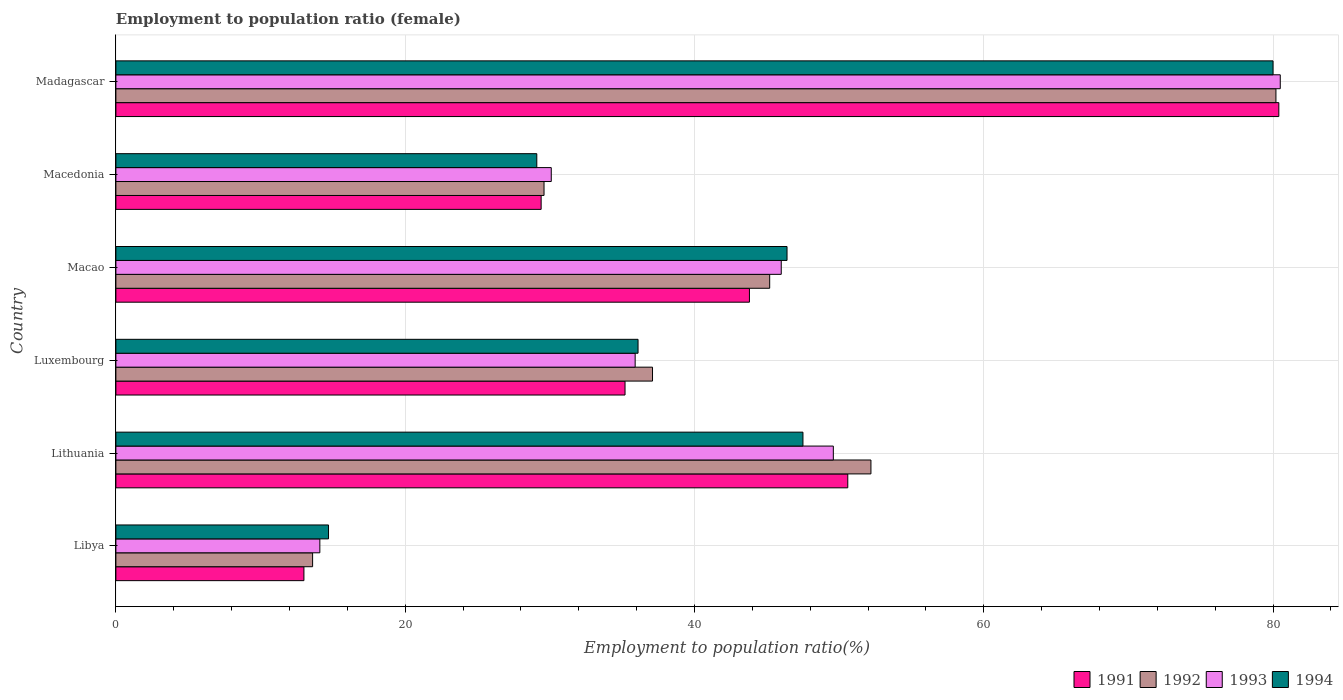How many different coloured bars are there?
Provide a succinct answer. 4. How many groups of bars are there?
Give a very brief answer. 6. Are the number of bars on each tick of the Y-axis equal?
Your response must be concise. Yes. How many bars are there on the 4th tick from the top?
Keep it short and to the point. 4. What is the label of the 6th group of bars from the top?
Keep it short and to the point. Libya. What is the employment to population ratio in 1994 in Luxembourg?
Make the answer very short. 36.1. Across all countries, what is the maximum employment to population ratio in 1991?
Offer a very short reply. 80.4. Across all countries, what is the minimum employment to population ratio in 1993?
Ensure brevity in your answer.  14.1. In which country was the employment to population ratio in 1991 maximum?
Offer a very short reply. Madagascar. In which country was the employment to population ratio in 1994 minimum?
Give a very brief answer. Libya. What is the total employment to population ratio in 1991 in the graph?
Ensure brevity in your answer.  252.4. What is the difference between the employment to population ratio in 1994 in Lithuania and that in Macedonia?
Your response must be concise. 18.4. What is the difference between the employment to population ratio in 1991 in Macao and the employment to population ratio in 1994 in Luxembourg?
Offer a very short reply. 7.7. What is the average employment to population ratio in 1992 per country?
Offer a terse response. 42.98. What is the difference between the employment to population ratio in 1992 and employment to population ratio in 1993 in Macao?
Your response must be concise. -0.8. What is the ratio of the employment to population ratio in 1992 in Luxembourg to that in Madagascar?
Provide a succinct answer. 0.46. Is the employment to population ratio in 1991 in Libya less than that in Macedonia?
Keep it short and to the point. Yes. What is the difference between the highest and the second highest employment to population ratio in 1994?
Offer a very short reply. 32.5. What is the difference between the highest and the lowest employment to population ratio in 1994?
Provide a succinct answer. 65.3. Is it the case that in every country, the sum of the employment to population ratio in 1994 and employment to population ratio in 1993 is greater than the sum of employment to population ratio in 1992 and employment to population ratio in 1991?
Give a very brief answer. No. What does the 1st bar from the bottom in Libya represents?
Ensure brevity in your answer.  1991. Is it the case that in every country, the sum of the employment to population ratio in 1992 and employment to population ratio in 1994 is greater than the employment to population ratio in 1993?
Give a very brief answer. Yes. What is the difference between two consecutive major ticks on the X-axis?
Offer a terse response. 20. Are the values on the major ticks of X-axis written in scientific E-notation?
Provide a short and direct response. No. Does the graph contain any zero values?
Your answer should be compact. No. Where does the legend appear in the graph?
Give a very brief answer. Bottom right. What is the title of the graph?
Provide a short and direct response. Employment to population ratio (female). Does "1994" appear as one of the legend labels in the graph?
Your answer should be compact. Yes. What is the label or title of the X-axis?
Provide a succinct answer. Employment to population ratio(%). What is the label or title of the Y-axis?
Ensure brevity in your answer.  Country. What is the Employment to population ratio(%) in 1991 in Libya?
Ensure brevity in your answer.  13. What is the Employment to population ratio(%) of 1992 in Libya?
Provide a short and direct response. 13.6. What is the Employment to population ratio(%) in 1993 in Libya?
Give a very brief answer. 14.1. What is the Employment to population ratio(%) in 1994 in Libya?
Your answer should be very brief. 14.7. What is the Employment to population ratio(%) in 1991 in Lithuania?
Your answer should be very brief. 50.6. What is the Employment to population ratio(%) in 1992 in Lithuania?
Offer a terse response. 52.2. What is the Employment to population ratio(%) of 1993 in Lithuania?
Provide a short and direct response. 49.6. What is the Employment to population ratio(%) of 1994 in Lithuania?
Give a very brief answer. 47.5. What is the Employment to population ratio(%) of 1991 in Luxembourg?
Offer a terse response. 35.2. What is the Employment to population ratio(%) in 1992 in Luxembourg?
Offer a terse response. 37.1. What is the Employment to population ratio(%) in 1993 in Luxembourg?
Give a very brief answer. 35.9. What is the Employment to population ratio(%) in 1994 in Luxembourg?
Offer a very short reply. 36.1. What is the Employment to population ratio(%) of 1991 in Macao?
Your answer should be very brief. 43.8. What is the Employment to population ratio(%) in 1992 in Macao?
Offer a terse response. 45.2. What is the Employment to population ratio(%) of 1994 in Macao?
Offer a terse response. 46.4. What is the Employment to population ratio(%) in 1991 in Macedonia?
Provide a short and direct response. 29.4. What is the Employment to population ratio(%) in 1992 in Macedonia?
Keep it short and to the point. 29.6. What is the Employment to population ratio(%) in 1993 in Macedonia?
Provide a short and direct response. 30.1. What is the Employment to population ratio(%) in 1994 in Macedonia?
Ensure brevity in your answer.  29.1. What is the Employment to population ratio(%) of 1991 in Madagascar?
Give a very brief answer. 80.4. What is the Employment to population ratio(%) in 1992 in Madagascar?
Make the answer very short. 80.2. What is the Employment to population ratio(%) of 1993 in Madagascar?
Offer a terse response. 80.5. What is the Employment to population ratio(%) of 1994 in Madagascar?
Your answer should be compact. 80. Across all countries, what is the maximum Employment to population ratio(%) in 1991?
Offer a very short reply. 80.4. Across all countries, what is the maximum Employment to population ratio(%) in 1992?
Your answer should be very brief. 80.2. Across all countries, what is the maximum Employment to population ratio(%) in 1993?
Your answer should be very brief. 80.5. Across all countries, what is the minimum Employment to population ratio(%) in 1992?
Offer a terse response. 13.6. Across all countries, what is the minimum Employment to population ratio(%) of 1993?
Ensure brevity in your answer.  14.1. Across all countries, what is the minimum Employment to population ratio(%) of 1994?
Your answer should be compact. 14.7. What is the total Employment to population ratio(%) in 1991 in the graph?
Your response must be concise. 252.4. What is the total Employment to population ratio(%) of 1992 in the graph?
Your answer should be compact. 257.9. What is the total Employment to population ratio(%) of 1993 in the graph?
Keep it short and to the point. 256.2. What is the total Employment to population ratio(%) in 1994 in the graph?
Make the answer very short. 253.8. What is the difference between the Employment to population ratio(%) in 1991 in Libya and that in Lithuania?
Offer a terse response. -37.6. What is the difference between the Employment to population ratio(%) in 1992 in Libya and that in Lithuania?
Give a very brief answer. -38.6. What is the difference between the Employment to population ratio(%) in 1993 in Libya and that in Lithuania?
Offer a terse response. -35.5. What is the difference between the Employment to population ratio(%) of 1994 in Libya and that in Lithuania?
Your answer should be compact. -32.8. What is the difference between the Employment to population ratio(%) of 1991 in Libya and that in Luxembourg?
Keep it short and to the point. -22.2. What is the difference between the Employment to population ratio(%) in 1992 in Libya and that in Luxembourg?
Your answer should be very brief. -23.5. What is the difference between the Employment to population ratio(%) in 1993 in Libya and that in Luxembourg?
Your response must be concise. -21.8. What is the difference between the Employment to population ratio(%) in 1994 in Libya and that in Luxembourg?
Your answer should be compact. -21.4. What is the difference between the Employment to population ratio(%) in 1991 in Libya and that in Macao?
Give a very brief answer. -30.8. What is the difference between the Employment to population ratio(%) in 1992 in Libya and that in Macao?
Your answer should be compact. -31.6. What is the difference between the Employment to population ratio(%) in 1993 in Libya and that in Macao?
Keep it short and to the point. -31.9. What is the difference between the Employment to population ratio(%) of 1994 in Libya and that in Macao?
Keep it short and to the point. -31.7. What is the difference between the Employment to population ratio(%) of 1991 in Libya and that in Macedonia?
Your response must be concise. -16.4. What is the difference between the Employment to population ratio(%) in 1992 in Libya and that in Macedonia?
Your answer should be very brief. -16. What is the difference between the Employment to population ratio(%) in 1993 in Libya and that in Macedonia?
Provide a succinct answer. -16. What is the difference between the Employment to population ratio(%) in 1994 in Libya and that in Macedonia?
Offer a very short reply. -14.4. What is the difference between the Employment to population ratio(%) of 1991 in Libya and that in Madagascar?
Give a very brief answer. -67.4. What is the difference between the Employment to population ratio(%) in 1992 in Libya and that in Madagascar?
Make the answer very short. -66.6. What is the difference between the Employment to population ratio(%) in 1993 in Libya and that in Madagascar?
Ensure brevity in your answer.  -66.4. What is the difference between the Employment to population ratio(%) in 1994 in Libya and that in Madagascar?
Offer a terse response. -65.3. What is the difference between the Employment to population ratio(%) of 1991 in Lithuania and that in Luxembourg?
Keep it short and to the point. 15.4. What is the difference between the Employment to population ratio(%) of 1994 in Lithuania and that in Luxembourg?
Keep it short and to the point. 11.4. What is the difference between the Employment to population ratio(%) in 1992 in Lithuania and that in Macao?
Your answer should be very brief. 7. What is the difference between the Employment to population ratio(%) in 1993 in Lithuania and that in Macao?
Make the answer very short. 3.6. What is the difference between the Employment to population ratio(%) of 1994 in Lithuania and that in Macao?
Offer a terse response. 1.1. What is the difference between the Employment to population ratio(%) of 1991 in Lithuania and that in Macedonia?
Provide a short and direct response. 21.2. What is the difference between the Employment to population ratio(%) of 1992 in Lithuania and that in Macedonia?
Offer a very short reply. 22.6. What is the difference between the Employment to population ratio(%) of 1993 in Lithuania and that in Macedonia?
Your answer should be compact. 19.5. What is the difference between the Employment to population ratio(%) of 1994 in Lithuania and that in Macedonia?
Offer a very short reply. 18.4. What is the difference between the Employment to population ratio(%) of 1991 in Lithuania and that in Madagascar?
Make the answer very short. -29.8. What is the difference between the Employment to population ratio(%) of 1993 in Lithuania and that in Madagascar?
Ensure brevity in your answer.  -30.9. What is the difference between the Employment to population ratio(%) of 1994 in Lithuania and that in Madagascar?
Your response must be concise. -32.5. What is the difference between the Employment to population ratio(%) in 1992 in Luxembourg and that in Macao?
Your answer should be very brief. -8.1. What is the difference between the Employment to population ratio(%) of 1993 in Luxembourg and that in Macao?
Keep it short and to the point. -10.1. What is the difference between the Employment to population ratio(%) of 1991 in Luxembourg and that in Madagascar?
Your answer should be compact. -45.2. What is the difference between the Employment to population ratio(%) in 1992 in Luxembourg and that in Madagascar?
Your answer should be very brief. -43.1. What is the difference between the Employment to population ratio(%) in 1993 in Luxembourg and that in Madagascar?
Provide a succinct answer. -44.6. What is the difference between the Employment to population ratio(%) of 1994 in Luxembourg and that in Madagascar?
Your response must be concise. -43.9. What is the difference between the Employment to population ratio(%) in 1991 in Macao and that in Macedonia?
Ensure brevity in your answer.  14.4. What is the difference between the Employment to population ratio(%) in 1991 in Macao and that in Madagascar?
Offer a terse response. -36.6. What is the difference between the Employment to population ratio(%) in 1992 in Macao and that in Madagascar?
Provide a succinct answer. -35. What is the difference between the Employment to population ratio(%) of 1993 in Macao and that in Madagascar?
Ensure brevity in your answer.  -34.5. What is the difference between the Employment to population ratio(%) in 1994 in Macao and that in Madagascar?
Provide a succinct answer. -33.6. What is the difference between the Employment to population ratio(%) in 1991 in Macedonia and that in Madagascar?
Keep it short and to the point. -51. What is the difference between the Employment to population ratio(%) in 1992 in Macedonia and that in Madagascar?
Keep it short and to the point. -50.6. What is the difference between the Employment to population ratio(%) of 1993 in Macedonia and that in Madagascar?
Provide a succinct answer. -50.4. What is the difference between the Employment to population ratio(%) in 1994 in Macedonia and that in Madagascar?
Give a very brief answer. -50.9. What is the difference between the Employment to population ratio(%) of 1991 in Libya and the Employment to population ratio(%) of 1992 in Lithuania?
Your answer should be compact. -39.2. What is the difference between the Employment to population ratio(%) of 1991 in Libya and the Employment to population ratio(%) of 1993 in Lithuania?
Your answer should be compact. -36.6. What is the difference between the Employment to population ratio(%) in 1991 in Libya and the Employment to population ratio(%) in 1994 in Lithuania?
Offer a terse response. -34.5. What is the difference between the Employment to population ratio(%) of 1992 in Libya and the Employment to population ratio(%) of 1993 in Lithuania?
Your response must be concise. -36. What is the difference between the Employment to population ratio(%) in 1992 in Libya and the Employment to population ratio(%) in 1994 in Lithuania?
Give a very brief answer. -33.9. What is the difference between the Employment to population ratio(%) of 1993 in Libya and the Employment to population ratio(%) of 1994 in Lithuania?
Give a very brief answer. -33.4. What is the difference between the Employment to population ratio(%) in 1991 in Libya and the Employment to population ratio(%) in 1992 in Luxembourg?
Make the answer very short. -24.1. What is the difference between the Employment to population ratio(%) of 1991 in Libya and the Employment to population ratio(%) of 1993 in Luxembourg?
Your answer should be very brief. -22.9. What is the difference between the Employment to population ratio(%) in 1991 in Libya and the Employment to population ratio(%) in 1994 in Luxembourg?
Keep it short and to the point. -23.1. What is the difference between the Employment to population ratio(%) in 1992 in Libya and the Employment to population ratio(%) in 1993 in Luxembourg?
Your response must be concise. -22.3. What is the difference between the Employment to population ratio(%) in 1992 in Libya and the Employment to population ratio(%) in 1994 in Luxembourg?
Offer a terse response. -22.5. What is the difference between the Employment to population ratio(%) in 1993 in Libya and the Employment to population ratio(%) in 1994 in Luxembourg?
Your answer should be very brief. -22. What is the difference between the Employment to population ratio(%) in 1991 in Libya and the Employment to population ratio(%) in 1992 in Macao?
Provide a succinct answer. -32.2. What is the difference between the Employment to population ratio(%) of 1991 in Libya and the Employment to population ratio(%) of 1993 in Macao?
Your answer should be very brief. -33. What is the difference between the Employment to population ratio(%) in 1991 in Libya and the Employment to population ratio(%) in 1994 in Macao?
Give a very brief answer. -33.4. What is the difference between the Employment to population ratio(%) of 1992 in Libya and the Employment to population ratio(%) of 1993 in Macao?
Make the answer very short. -32.4. What is the difference between the Employment to population ratio(%) in 1992 in Libya and the Employment to population ratio(%) in 1994 in Macao?
Your answer should be compact. -32.8. What is the difference between the Employment to population ratio(%) in 1993 in Libya and the Employment to population ratio(%) in 1994 in Macao?
Make the answer very short. -32.3. What is the difference between the Employment to population ratio(%) of 1991 in Libya and the Employment to population ratio(%) of 1992 in Macedonia?
Make the answer very short. -16.6. What is the difference between the Employment to population ratio(%) in 1991 in Libya and the Employment to population ratio(%) in 1993 in Macedonia?
Keep it short and to the point. -17.1. What is the difference between the Employment to population ratio(%) of 1991 in Libya and the Employment to population ratio(%) of 1994 in Macedonia?
Provide a short and direct response. -16.1. What is the difference between the Employment to population ratio(%) of 1992 in Libya and the Employment to population ratio(%) of 1993 in Macedonia?
Provide a succinct answer. -16.5. What is the difference between the Employment to population ratio(%) in 1992 in Libya and the Employment to population ratio(%) in 1994 in Macedonia?
Your answer should be compact. -15.5. What is the difference between the Employment to population ratio(%) of 1993 in Libya and the Employment to population ratio(%) of 1994 in Macedonia?
Your answer should be compact. -15. What is the difference between the Employment to population ratio(%) of 1991 in Libya and the Employment to population ratio(%) of 1992 in Madagascar?
Provide a succinct answer. -67.2. What is the difference between the Employment to population ratio(%) in 1991 in Libya and the Employment to population ratio(%) in 1993 in Madagascar?
Offer a very short reply. -67.5. What is the difference between the Employment to population ratio(%) of 1991 in Libya and the Employment to population ratio(%) of 1994 in Madagascar?
Your answer should be compact. -67. What is the difference between the Employment to population ratio(%) in 1992 in Libya and the Employment to population ratio(%) in 1993 in Madagascar?
Make the answer very short. -66.9. What is the difference between the Employment to population ratio(%) of 1992 in Libya and the Employment to population ratio(%) of 1994 in Madagascar?
Offer a terse response. -66.4. What is the difference between the Employment to population ratio(%) of 1993 in Libya and the Employment to population ratio(%) of 1994 in Madagascar?
Give a very brief answer. -65.9. What is the difference between the Employment to population ratio(%) in 1991 in Lithuania and the Employment to population ratio(%) in 1992 in Luxembourg?
Provide a succinct answer. 13.5. What is the difference between the Employment to population ratio(%) of 1991 in Lithuania and the Employment to population ratio(%) of 1993 in Luxembourg?
Provide a short and direct response. 14.7. What is the difference between the Employment to population ratio(%) in 1991 in Lithuania and the Employment to population ratio(%) in 1994 in Luxembourg?
Offer a terse response. 14.5. What is the difference between the Employment to population ratio(%) in 1991 in Lithuania and the Employment to population ratio(%) in 1992 in Macao?
Your answer should be compact. 5.4. What is the difference between the Employment to population ratio(%) of 1991 in Lithuania and the Employment to population ratio(%) of 1994 in Macao?
Offer a very short reply. 4.2. What is the difference between the Employment to population ratio(%) of 1992 in Lithuania and the Employment to population ratio(%) of 1994 in Macao?
Your answer should be compact. 5.8. What is the difference between the Employment to population ratio(%) in 1993 in Lithuania and the Employment to population ratio(%) in 1994 in Macao?
Keep it short and to the point. 3.2. What is the difference between the Employment to population ratio(%) of 1992 in Lithuania and the Employment to population ratio(%) of 1993 in Macedonia?
Provide a short and direct response. 22.1. What is the difference between the Employment to population ratio(%) of 1992 in Lithuania and the Employment to population ratio(%) of 1994 in Macedonia?
Offer a very short reply. 23.1. What is the difference between the Employment to population ratio(%) of 1993 in Lithuania and the Employment to population ratio(%) of 1994 in Macedonia?
Offer a very short reply. 20.5. What is the difference between the Employment to population ratio(%) in 1991 in Lithuania and the Employment to population ratio(%) in 1992 in Madagascar?
Give a very brief answer. -29.6. What is the difference between the Employment to population ratio(%) of 1991 in Lithuania and the Employment to population ratio(%) of 1993 in Madagascar?
Provide a succinct answer. -29.9. What is the difference between the Employment to population ratio(%) in 1991 in Lithuania and the Employment to population ratio(%) in 1994 in Madagascar?
Your answer should be compact. -29.4. What is the difference between the Employment to population ratio(%) of 1992 in Lithuania and the Employment to population ratio(%) of 1993 in Madagascar?
Offer a very short reply. -28.3. What is the difference between the Employment to population ratio(%) in 1992 in Lithuania and the Employment to population ratio(%) in 1994 in Madagascar?
Make the answer very short. -27.8. What is the difference between the Employment to population ratio(%) of 1993 in Lithuania and the Employment to population ratio(%) of 1994 in Madagascar?
Provide a short and direct response. -30.4. What is the difference between the Employment to population ratio(%) in 1991 in Luxembourg and the Employment to population ratio(%) in 1992 in Macao?
Give a very brief answer. -10. What is the difference between the Employment to population ratio(%) in 1993 in Luxembourg and the Employment to population ratio(%) in 1994 in Macao?
Your response must be concise. -10.5. What is the difference between the Employment to population ratio(%) in 1991 in Luxembourg and the Employment to population ratio(%) in 1994 in Macedonia?
Provide a succinct answer. 6.1. What is the difference between the Employment to population ratio(%) of 1992 in Luxembourg and the Employment to population ratio(%) of 1993 in Macedonia?
Provide a short and direct response. 7. What is the difference between the Employment to population ratio(%) of 1992 in Luxembourg and the Employment to population ratio(%) of 1994 in Macedonia?
Offer a terse response. 8. What is the difference between the Employment to population ratio(%) in 1993 in Luxembourg and the Employment to population ratio(%) in 1994 in Macedonia?
Ensure brevity in your answer.  6.8. What is the difference between the Employment to population ratio(%) in 1991 in Luxembourg and the Employment to population ratio(%) in 1992 in Madagascar?
Provide a succinct answer. -45. What is the difference between the Employment to population ratio(%) of 1991 in Luxembourg and the Employment to population ratio(%) of 1993 in Madagascar?
Give a very brief answer. -45.3. What is the difference between the Employment to population ratio(%) in 1991 in Luxembourg and the Employment to population ratio(%) in 1994 in Madagascar?
Ensure brevity in your answer.  -44.8. What is the difference between the Employment to population ratio(%) in 1992 in Luxembourg and the Employment to population ratio(%) in 1993 in Madagascar?
Offer a terse response. -43.4. What is the difference between the Employment to population ratio(%) of 1992 in Luxembourg and the Employment to population ratio(%) of 1994 in Madagascar?
Your answer should be very brief. -42.9. What is the difference between the Employment to population ratio(%) of 1993 in Luxembourg and the Employment to population ratio(%) of 1994 in Madagascar?
Your answer should be very brief. -44.1. What is the difference between the Employment to population ratio(%) in 1991 in Macao and the Employment to population ratio(%) in 1992 in Macedonia?
Offer a very short reply. 14.2. What is the difference between the Employment to population ratio(%) in 1991 in Macao and the Employment to population ratio(%) in 1993 in Macedonia?
Your answer should be compact. 13.7. What is the difference between the Employment to population ratio(%) of 1991 in Macao and the Employment to population ratio(%) of 1994 in Macedonia?
Your answer should be compact. 14.7. What is the difference between the Employment to population ratio(%) of 1992 in Macao and the Employment to population ratio(%) of 1994 in Macedonia?
Your response must be concise. 16.1. What is the difference between the Employment to population ratio(%) of 1993 in Macao and the Employment to population ratio(%) of 1994 in Macedonia?
Provide a short and direct response. 16.9. What is the difference between the Employment to population ratio(%) of 1991 in Macao and the Employment to population ratio(%) of 1992 in Madagascar?
Ensure brevity in your answer.  -36.4. What is the difference between the Employment to population ratio(%) in 1991 in Macao and the Employment to population ratio(%) in 1993 in Madagascar?
Your answer should be compact. -36.7. What is the difference between the Employment to population ratio(%) in 1991 in Macao and the Employment to population ratio(%) in 1994 in Madagascar?
Ensure brevity in your answer.  -36.2. What is the difference between the Employment to population ratio(%) in 1992 in Macao and the Employment to population ratio(%) in 1993 in Madagascar?
Offer a terse response. -35.3. What is the difference between the Employment to population ratio(%) of 1992 in Macao and the Employment to population ratio(%) of 1994 in Madagascar?
Provide a succinct answer. -34.8. What is the difference between the Employment to population ratio(%) of 1993 in Macao and the Employment to population ratio(%) of 1994 in Madagascar?
Ensure brevity in your answer.  -34. What is the difference between the Employment to population ratio(%) of 1991 in Macedonia and the Employment to population ratio(%) of 1992 in Madagascar?
Offer a terse response. -50.8. What is the difference between the Employment to population ratio(%) of 1991 in Macedonia and the Employment to population ratio(%) of 1993 in Madagascar?
Keep it short and to the point. -51.1. What is the difference between the Employment to population ratio(%) in 1991 in Macedonia and the Employment to population ratio(%) in 1994 in Madagascar?
Give a very brief answer. -50.6. What is the difference between the Employment to population ratio(%) of 1992 in Macedonia and the Employment to population ratio(%) of 1993 in Madagascar?
Your answer should be compact. -50.9. What is the difference between the Employment to population ratio(%) in 1992 in Macedonia and the Employment to population ratio(%) in 1994 in Madagascar?
Provide a short and direct response. -50.4. What is the difference between the Employment to population ratio(%) of 1993 in Macedonia and the Employment to population ratio(%) of 1994 in Madagascar?
Provide a short and direct response. -49.9. What is the average Employment to population ratio(%) of 1991 per country?
Your answer should be compact. 42.07. What is the average Employment to population ratio(%) of 1992 per country?
Provide a short and direct response. 42.98. What is the average Employment to population ratio(%) in 1993 per country?
Give a very brief answer. 42.7. What is the average Employment to population ratio(%) of 1994 per country?
Your answer should be compact. 42.3. What is the difference between the Employment to population ratio(%) in 1991 and Employment to population ratio(%) in 1992 in Libya?
Keep it short and to the point. -0.6. What is the difference between the Employment to population ratio(%) of 1992 and Employment to population ratio(%) of 1994 in Libya?
Keep it short and to the point. -1.1. What is the difference between the Employment to population ratio(%) of 1993 and Employment to population ratio(%) of 1994 in Libya?
Ensure brevity in your answer.  -0.6. What is the difference between the Employment to population ratio(%) of 1991 and Employment to population ratio(%) of 1993 in Lithuania?
Your response must be concise. 1. What is the difference between the Employment to population ratio(%) of 1991 and Employment to population ratio(%) of 1994 in Lithuania?
Give a very brief answer. 3.1. What is the difference between the Employment to population ratio(%) of 1991 and Employment to population ratio(%) of 1993 in Luxembourg?
Your answer should be very brief. -0.7. What is the difference between the Employment to population ratio(%) in 1991 and Employment to population ratio(%) in 1994 in Luxembourg?
Offer a terse response. -0.9. What is the difference between the Employment to population ratio(%) in 1991 and Employment to population ratio(%) in 1993 in Macao?
Your answer should be compact. -2.2. What is the difference between the Employment to population ratio(%) in 1991 and Employment to population ratio(%) in 1992 in Macedonia?
Your response must be concise. -0.2. What is the difference between the Employment to population ratio(%) in 1991 and Employment to population ratio(%) in 1994 in Macedonia?
Your response must be concise. 0.3. What is the difference between the Employment to population ratio(%) of 1992 and Employment to population ratio(%) of 1993 in Macedonia?
Your answer should be very brief. -0.5. What is the difference between the Employment to population ratio(%) in 1992 and Employment to population ratio(%) in 1994 in Macedonia?
Keep it short and to the point. 0.5. What is the difference between the Employment to population ratio(%) of 1991 and Employment to population ratio(%) of 1992 in Madagascar?
Offer a very short reply. 0.2. What is the difference between the Employment to population ratio(%) in 1991 and Employment to population ratio(%) in 1993 in Madagascar?
Offer a terse response. -0.1. What is the difference between the Employment to population ratio(%) in 1991 and Employment to population ratio(%) in 1994 in Madagascar?
Offer a terse response. 0.4. What is the difference between the Employment to population ratio(%) of 1992 and Employment to population ratio(%) of 1993 in Madagascar?
Offer a very short reply. -0.3. What is the difference between the Employment to population ratio(%) in 1992 and Employment to population ratio(%) in 1994 in Madagascar?
Offer a very short reply. 0.2. What is the difference between the Employment to population ratio(%) in 1993 and Employment to population ratio(%) in 1994 in Madagascar?
Offer a terse response. 0.5. What is the ratio of the Employment to population ratio(%) of 1991 in Libya to that in Lithuania?
Provide a succinct answer. 0.26. What is the ratio of the Employment to population ratio(%) in 1992 in Libya to that in Lithuania?
Your answer should be very brief. 0.26. What is the ratio of the Employment to population ratio(%) in 1993 in Libya to that in Lithuania?
Provide a succinct answer. 0.28. What is the ratio of the Employment to population ratio(%) of 1994 in Libya to that in Lithuania?
Keep it short and to the point. 0.31. What is the ratio of the Employment to population ratio(%) in 1991 in Libya to that in Luxembourg?
Ensure brevity in your answer.  0.37. What is the ratio of the Employment to population ratio(%) in 1992 in Libya to that in Luxembourg?
Offer a very short reply. 0.37. What is the ratio of the Employment to population ratio(%) in 1993 in Libya to that in Luxembourg?
Your answer should be compact. 0.39. What is the ratio of the Employment to population ratio(%) in 1994 in Libya to that in Luxembourg?
Ensure brevity in your answer.  0.41. What is the ratio of the Employment to population ratio(%) of 1991 in Libya to that in Macao?
Ensure brevity in your answer.  0.3. What is the ratio of the Employment to population ratio(%) of 1992 in Libya to that in Macao?
Make the answer very short. 0.3. What is the ratio of the Employment to population ratio(%) in 1993 in Libya to that in Macao?
Your response must be concise. 0.31. What is the ratio of the Employment to population ratio(%) of 1994 in Libya to that in Macao?
Offer a terse response. 0.32. What is the ratio of the Employment to population ratio(%) in 1991 in Libya to that in Macedonia?
Provide a succinct answer. 0.44. What is the ratio of the Employment to population ratio(%) in 1992 in Libya to that in Macedonia?
Provide a succinct answer. 0.46. What is the ratio of the Employment to population ratio(%) in 1993 in Libya to that in Macedonia?
Give a very brief answer. 0.47. What is the ratio of the Employment to population ratio(%) of 1994 in Libya to that in Macedonia?
Make the answer very short. 0.51. What is the ratio of the Employment to population ratio(%) of 1991 in Libya to that in Madagascar?
Your answer should be very brief. 0.16. What is the ratio of the Employment to population ratio(%) of 1992 in Libya to that in Madagascar?
Your response must be concise. 0.17. What is the ratio of the Employment to population ratio(%) of 1993 in Libya to that in Madagascar?
Provide a succinct answer. 0.18. What is the ratio of the Employment to population ratio(%) in 1994 in Libya to that in Madagascar?
Give a very brief answer. 0.18. What is the ratio of the Employment to population ratio(%) of 1991 in Lithuania to that in Luxembourg?
Make the answer very short. 1.44. What is the ratio of the Employment to population ratio(%) in 1992 in Lithuania to that in Luxembourg?
Your answer should be very brief. 1.41. What is the ratio of the Employment to population ratio(%) in 1993 in Lithuania to that in Luxembourg?
Keep it short and to the point. 1.38. What is the ratio of the Employment to population ratio(%) in 1994 in Lithuania to that in Luxembourg?
Your answer should be very brief. 1.32. What is the ratio of the Employment to population ratio(%) of 1991 in Lithuania to that in Macao?
Provide a succinct answer. 1.16. What is the ratio of the Employment to population ratio(%) of 1992 in Lithuania to that in Macao?
Give a very brief answer. 1.15. What is the ratio of the Employment to population ratio(%) in 1993 in Lithuania to that in Macao?
Make the answer very short. 1.08. What is the ratio of the Employment to population ratio(%) in 1994 in Lithuania to that in Macao?
Your answer should be compact. 1.02. What is the ratio of the Employment to population ratio(%) in 1991 in Lithuania to that in Macedonia?
Your response must be concise. 1.72. What is the ratio of the Employment to population ratio(%) of 1992 in Lithuania to that in Macedonia?
Provide a short and direct response. 1.76. What is the ratio of the Employment to population ratio(%) of 1993 in Lithuania to that in Macedonia?
Offer a very short reply. 1.65. What is the ratio of the Employment to population ratio(%) of 1994 in Lithuania to that in Macedonia?
Offer a very short reply. 1.63. What is the ratio of the Employment to population ratio(%) in 1991 in Lithuania to that in Madagascar?
Provide a succinct answer. 0.63. What is the ratio of the Employment to population ratio(%) in 1992 in Lithuania to that in Madagascar?
Your response must be concise. 0.65. What is the ratio of the Employment to population ratio(%) of 1993 in Lithuania to that in Madagascar?
Provide a short and direct response. 0.62. What is the ratio of the Employment to population ratio(%) in 1994 in Lithuania to that in Madagascar?
Your response must be concise. 0.59. What is the ratio of the Employment to population ratio(%) in 1991 in Luxembourg to that in Macao?
Your response must be concise. 0.8. What is the ratio of the Employment to population ratio(%) in 1992 in Luxembourg to that in Macao?
Provide a succinct answer. 0.82. What is the ratio of the Employment to population ratio(%) in 1993 in Luxembourg to that in Macao?
Give a very brief answer. 0.78. What is the ratio of the Employment to population ratio(%) of 1994 in Luxembourg to that in Macao?
Your answer should be compact. 0.78. What is the ratio of the Employment to population ratio(%) of 1991 in Luxembourg to that in Macedonia?
Your response must be concise. 1.2. What is the ratio of the Employment to population ratio(%) of 1992 in Luxembourg to that in Macedonia?
Your answer should be compact. 1.25. What is the ratio of the Employment to population ratio(%) in 1993 in Luxembourg to that in Macedonia?
Your answer should be very brief. 1.19. What is the ratio of the Employment to population ratio(%) of 1994 in Luxembourg to that in Macedonia?
Your answer should be very brief. 1.24. What is the ratio of the Employment to population ratio(%) in 1991 in Luxembourg to that in Madagascar?
Your answer should be compact. 0.44. What is the ratio of the Employment to population ratio(%) of 1992 in Luxembourg to that in Madagascar?
Keep it short and to the point. 0.46. What is the ratio of the Employment to population ratio(%) in 1993 in Luxembourg to that in Madagascar?
Your answer should be compact. 0.45. What is the ratio of the Employment to population ratio(%) in 1994 in Luxembourg to that in Madagascar?
Make the answer very short. 0.45. What is the ratio of the Employment to population ratio(%) in 1991 in Macao to that in Macedonia?
Your response must be concise. 1.49. What is the ratio of the Employment to population ratio(%) in 1992 in Macao to that in Macedonia?
Give a very brief answer. 1.53. What is the ratio of the Employment to population ratio(%) of 1993 in Macao to that in Macedonia?
Offer a terse response. 1.53. What is the ratio of the Employment to population ratio(%) of 1994 in Macao to that in Macedonia?
Make the answer very short. 1.59. What is the ratio of the Employment to population ratio(%) of 1991 in Macao to that in Madagascar?
Your response must be concise. 0.54. What is the ratio of the Employment to population ratio(%) of 1992 in Macao to that in Madagascar?
Your answer should be very brief. 0.56. What is the ratio of the Employment to population ratio(%) of 1993 in Macao to that in Madagascar?
Give a very brief answer. 0.57. What is the ratio of the Employment to population ratio(%) in 1994 in Macao to that in Madagascar?
Provide a succinct answer. 0.58. What is the ratio of the Employment to population ratio(%) in 1991 in Macedonia to that in Madagascar?
Give a very brief answer. 0.37. What is the ratio of the Employment to population ratio(%) of 1992 in Macedonia to that in Madagascar?
Provide a short and direct response. 0.37. What is the ratio of the Employment to population ratio(%) in 1993 in Macedonia to that in Madagascar?
Keep it short and to the point. 0.37. What is the ratio of the Employment to population ratio(%) of 1994 in Macedonia to that in Madagascar?
Offer a terse response. 0.36. What is the difference between the highest and the second highest Employment to population ratio(%) of 1991?
Make the answer very short. 29.8. What is the difference between the highest and the second highest Employment to population ratio(%) in 1992?
Your response must be concise. 28. What is the difference between the highest and the second highest Employment to population ratio(%) of 1993?
Make the answer very short. 30.9. What is the difference between the highest and the second highest Employment to population ratio(%) of 1994?
Offer a very short reply. 32.5. What is the difference between the highest and the lowest Employment to population ratio(%) in 1991?
Provide a succinct answer. 67.4. What is the difference between the highest and the lowest Employment to population ratio(%) of 1992?
Make the answer very short. 66.6. What is the difference between the highest and the lowest Employment to population ratio(%) in 1993?
Ensure brevity in your answer.  66.4. What is the difference between the highest and the lowest Employment to population ratio(%) of 1994?
Your answer should be compact. 65.3. 